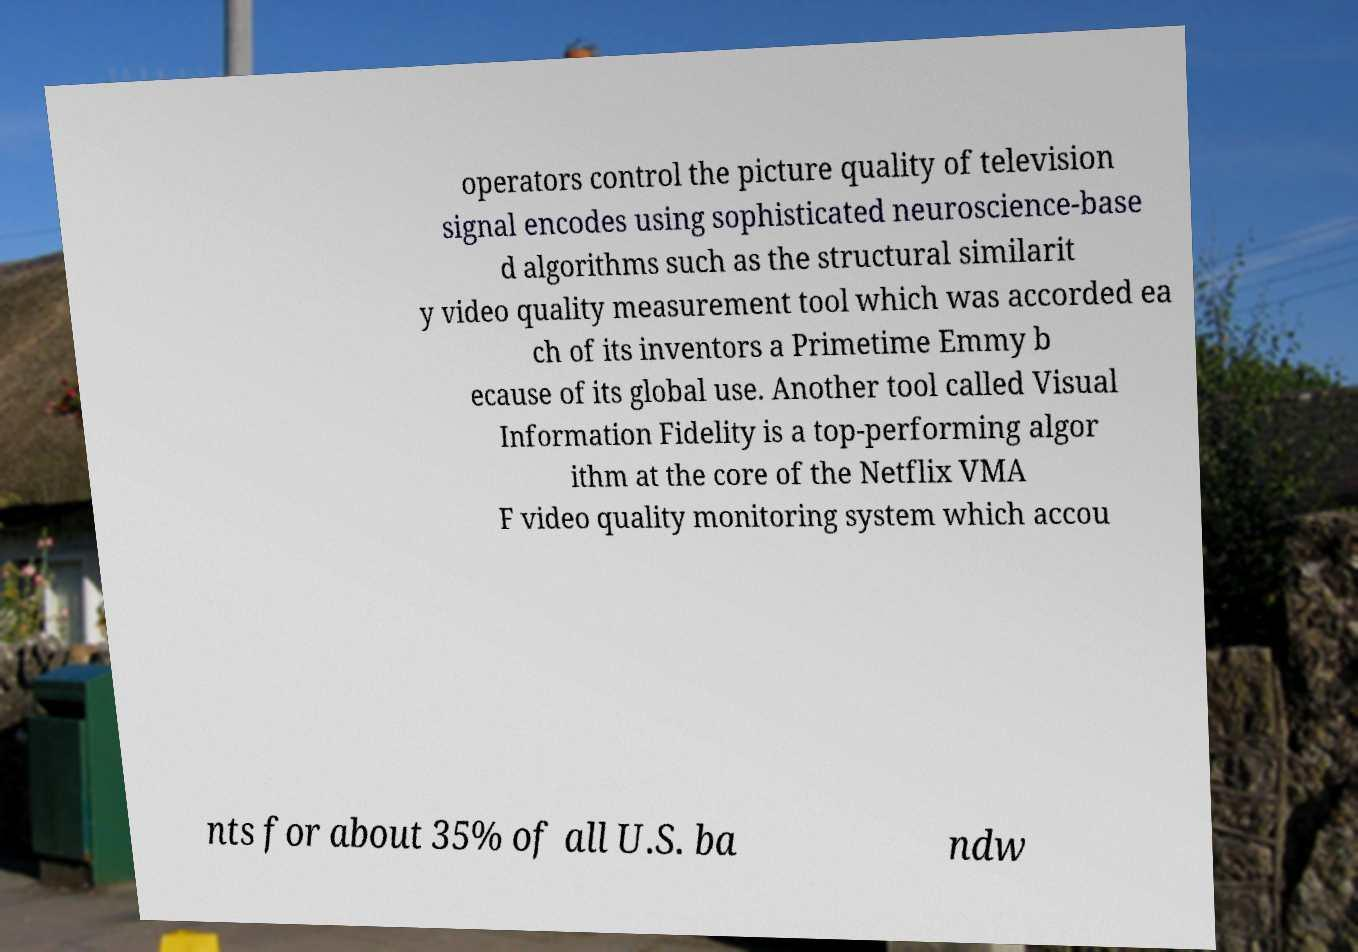There's text embedded in this image that I need extracted. Can you transcribe it verbatim? operators control the picture quality of television signal encodes using sophisticated neuroscience-base d algorithms such as the structural similarit y video quality measurement tool which was accorded ea ch of its inventors a Primetime Emmy b ecause of its global use. Another tool called Visual Information Fidelity is a top-performing algor ithm at the core of the Netflix VMA F video quality monitoring system which accou nts for about 35% of all U.S. ba ndw 